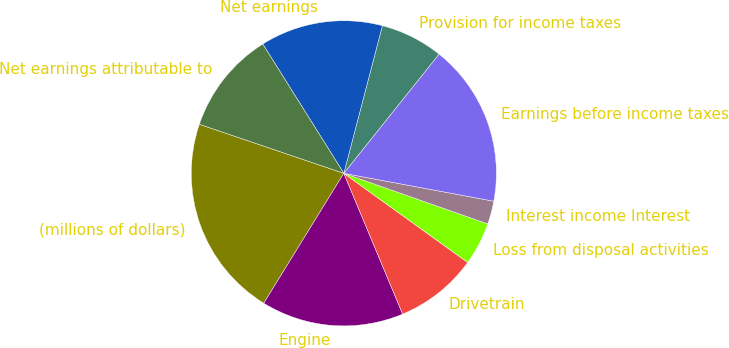<chart> <loc_0><loc_0><loc_500><loc_500><pie_chart><fcel>(millions of dollars)<fcel>Engine<fcel>Drivetrain<fcel>Loss from disposal activities<fcel>Interest income Interest<fcel>Earnings before income taxes<fcel>Provision for income taxes<fcel>Net earnings<fcel>Net earnings attributable to<nl><fcel>21.42%<fcel>15.09%<fcel>8.77%<fcel>4.55%<fcel>2.45%<fcel>17.2%<fcel>6.66%<fcel>12.98%<fcel>10.88%<nl></chart> 